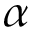<formula> <loc_0><loc_0><loc_500><loc_500>\alpha</formula> 